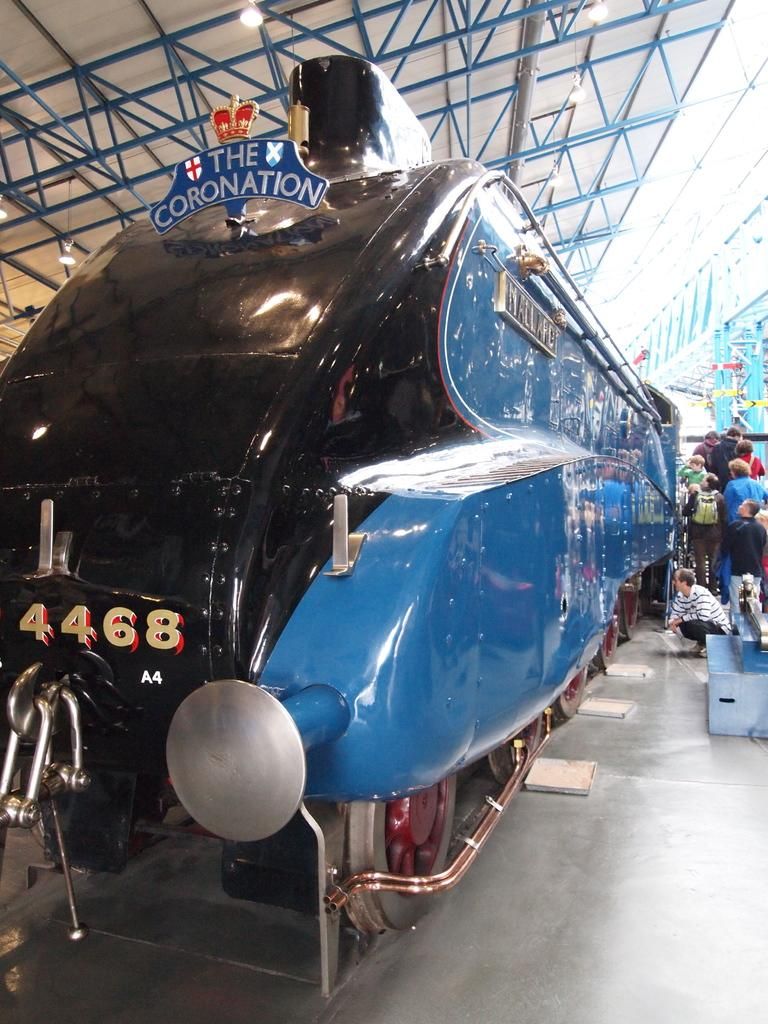What is the main subject of the image? The main subject of the image is a train. Can you describe the position of the train in the image? The train is standing on the floor in the image. Are there any people present in the image? Yes, there are people standing near the train. What degree of difficulty does the train have in the image? The image does not provide any information about the difficulty level of the train. The train is simply standing on the floor, and there is no indication of any challenges or difficulties it might be facing. 